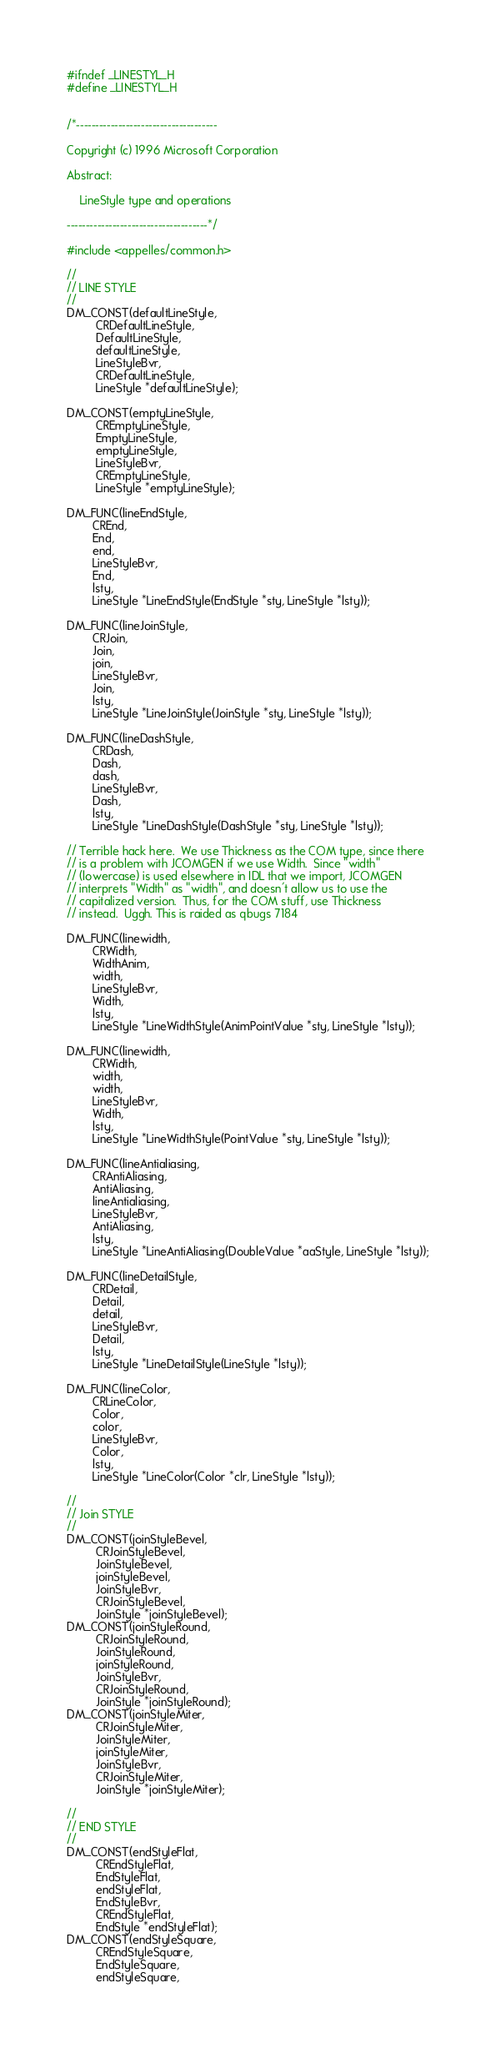<code> <loc_0><loc_0><loc_500><loc_500><_C_>#ifndef _LINESTYL_H
#define _LINESTYL_H


/*-------------------------------------

Copyright (c) 1996 Microsoft Corporation

Abstract:

    LineStyle type and operations

-------------------------------------*/

#include <appelles/common.h>

//
// LINE STYLE
//
DM_CONST(defaultLineStyle,
         CRDefaultLineStyle,
         DefaultLineStyle,
         defaultLineStyle,
         LineStyleBvr,
         CRDefaultLineStyle,
         LineStyle *defaultLineStyle);

DM_CONST(emptyLineStyle,
         CREmptyLineStyle,
         EmptyLineStyle,
         emptyLineStyle,
         LineStyleBvr,
         CREmptyLineStyle,
         LineStyle *emptyLineStyle);

DM_FUNC(lineEndStyle,
        CREnd,
        End,
        end,
        LineStyleBvr,
        End,
        lsty,
        LineStyle *LineEndStyle(EndStyle *sty, LineStyle *lsty));

DM_FUNC(lineJoinStyle,
        CRJoin,
        Join,
        join,
        LineStyleBvr,
        Join,
        lsty,
        LineStyle *LineJoinStyle(JoinStyle *sty, LineStyle *lsty));

DM_FUNC(lineDashStyle,
        CRDash,
        Dash,
        dash,
        LineStyleBvr,
        Dash,
        lsty,
        LineStyle *LineDashStyle(DashStyle *sty, LineStyle *lsty));

// Terrible hack here.  We use Thickness as the COM type, since there
// is a problem with JCOMGEN if we use Width.  Since "width"
// (lowercase) is used elsewhere in IDL that we import, JCOMGEN
// interprets "Width" as "width", and doesn't allow us to use the
// capitalized version.  Thus, for the COM stuff, use Thickness
// instead.  Uggh. This is raided as qbugs 7184

DM_FUNC(linewidth,
        CRWidth,
        WidthAnim,
        width,
        LineStyleBvr,
        Width,
        lsty,
        LineStyle *LineWidthStyle(AnimPointValue *sty, LineStyle *lsty));

DM_FUNC(linewidth,
        CRWidth,
        width,
        width,
        LineStyleBvr,
        Width,
        lsty,
        LineStyle *LineWidthStyle(PointValue *sty, LineStyle *lsty));

DM_FUNC(lineAntialiasing,
        CRAntiAliasing,
        AntiAliasing,
        lineAntialiasing,
        LineStyleBvr,
        AntiAliasing,
        lsty,
        LineStyle *LineAntiAliasing(DoubleValue *aaStyle, LineStyle *lsty));

DM_FUNC(lineDetailStyle,
        CRDetail,
        Detail,
        detail,
        LineStyleBvr,
        Detail,
        lsty,
        LineStyle *LineDetailStyle(LineStyle *lsty));

DM_FUNC(lineColor,
        CRLineColor,
        Color,
        color,
        LineStyleBvr,
        Color,
        lsty,
        LineStyle *LineColor(Color *clr, LineStyle *lsty));

//
// Join STYLE
//
DM_CONST(joinStyleBevel,
         CRJoinStyleBevel,
         JoinStyleBevel,
         joinStyleBevel,
         JoinStyleBvr,
         CRJoinStyleBevel,
         JoinStyle *joinStyleBevel);
DM_CONST(joinStyleRound,
         CRJoinStyleRound,
         JoinStyleRound,
         joinStyleRound,
         JoinStyleBvr,
         CRJoinStyleRound,
         JoinStyle *joinStyleRound);
DM_CONST(joinStyleMiter,
         CRJoinStyleMiter,
         JoinStyleMiter,
         joinStyleMiter,
         JoinStyleBvr,
         CRJoinStyleMiter,
         JoinStyle *joinStyleMiter);

//
// END STYLE
//
DM_CONST(endStyleFlat,
         CREndStyleFlat,
         EndStyleFlat,
         endStyleFlat,
         EndStyleBvr,
         CREndStyleFlat,
         EndStyle *endStyleFlat);
DM_CONST(endStyleSquare,
         CREndStyleSquare,
         EndStyleSquare,
         endStyleSquare,</code> 